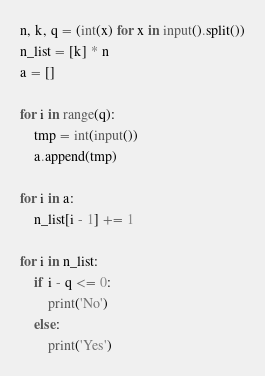Convert code to text. <code><loc_0><loc_0><loc_500><loc_500><_Python_>n, k, q = (int(x) for x in input().split())
n_list = [k] * n
a = []

for i in range(q):
    tmp = int(input())
    a.append(tmp)

for i in a:
    n_list[i - 1] += 1

for i in n_list:
    if i - q <= 0:
        print('No')
    else:
        print('Yes')</code> 